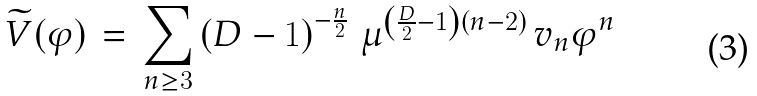<formula> <loc_0><loc_0><loc_500><loc_500>\widetilde { V } ( \varphi ) \, = \, \sum _ { n \geq 3 } \left ( D - 1 \right ) ^ { - \frac { n } { 2 } } \, \mu ^ { \left ( \frac { D } { 2 } - 1 \right ) ( n - 2 ) } \, v _ { n } \varphi ^ { n }</formula> 